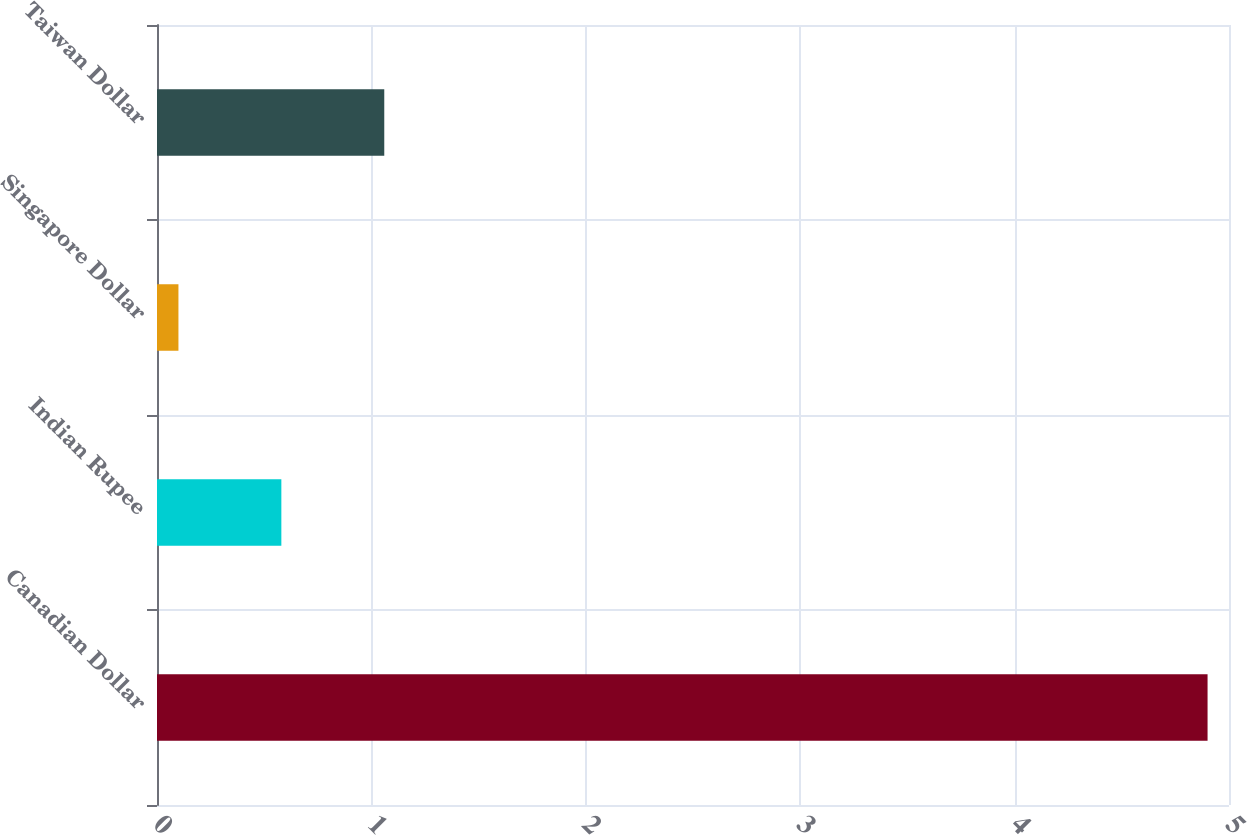Convert chart. <chart><loc_0><loc_0><loc_500><loc_500><bar_chart><fcel>Canadian Dollar<fcel>Indian Rupee<fcel>Singapore Dollar<fcel>Taiwan Dollar<nl><fcel>4.9<fcel>0.58<fcel>0.1<fcel>1.06<nl></chart> 